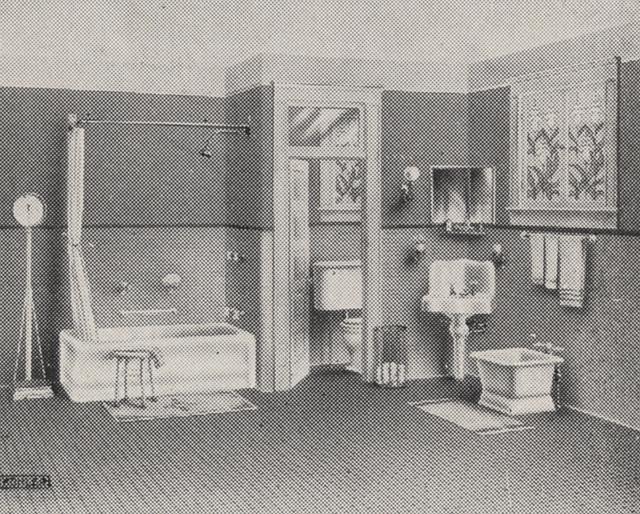What room is this?
Short answer required. Bathroom. Was this picture taken more than five years ago?
Short answer required. Yes. Is the picture in color?
Answer briefly. No. 